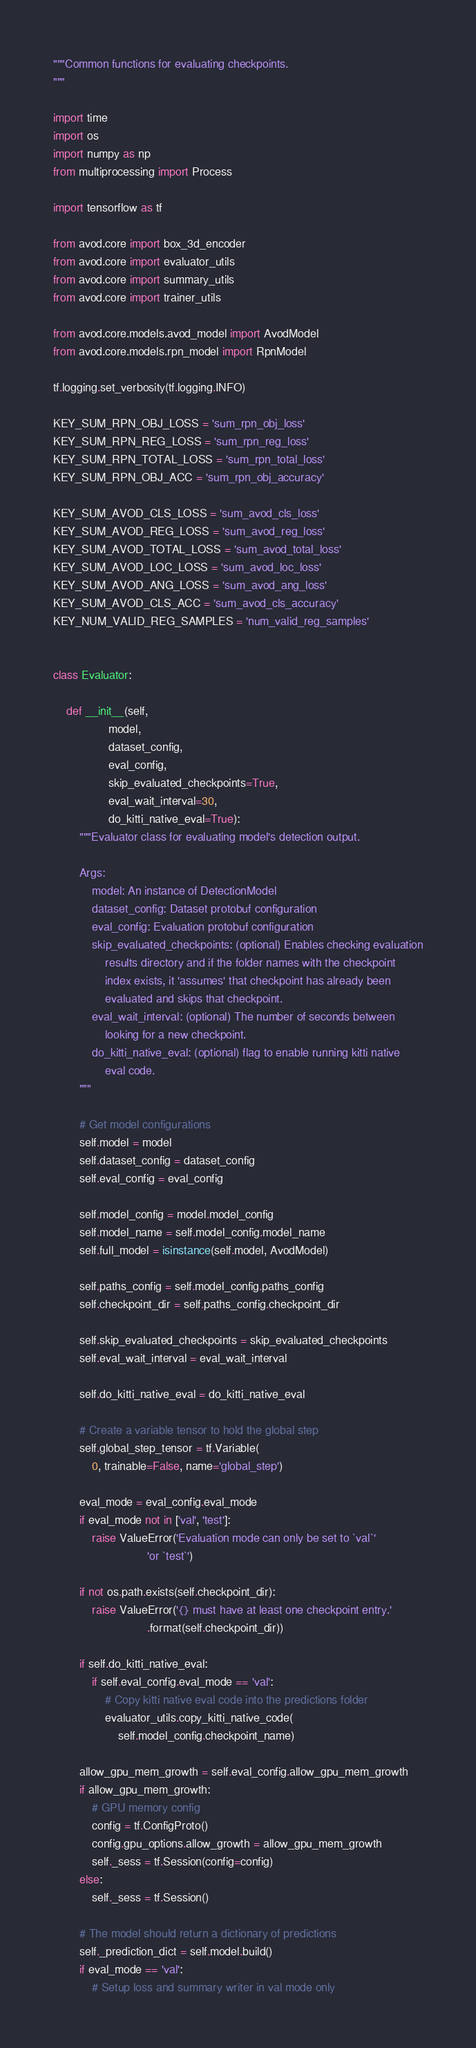<code> <loc_0><loc_0><loc_500><loc_500><_Python_>"""Common functions for evaluating checkpoints.
"""

import time
import os
import numpy as np
from multiprocessing import Process

import tensorflow as tf

from avod.core import box_3d_encoder
from avod.core import evaluator_utils
from avod.core import summary_utils
from avod.core import trainer_utils

from avod.core.models.avod_model import AvodModel
from avod.core.models.rpn_model import RpnModel

tf.logging.set_verbosity(tf.logging.INFO)

KEY_SUM_RPN_OBJ_LOSS = 'sum_rpn_obj_loss'
KEY_SUM_RPN_REG_LOSS = 'sum_rpn_reg_loss'
KEY_SUM_RPN_TOTAL_LOSS = 'sum_rpn_total_loss'
KEY_SUM_RPN_OBJ_ACC = 'sum_rpn_obj_accuracy'

KEY_SUM_AVOD_CLS_LOSS = 'sum_avod_cls_loss'
KEY_SUM_AVOD_REG_LOSS = 'sum_avod_reg_loss'
KEY_SUM_AVOD_TOTAL_LOSS = 'sum_avod_total_loss'
KEY_SUM_AVOD_LOC_LOSS = 'sum_avod_loc_loss'
KEY_SUM_AVOD_ANG_LOSS = 'sum_avod_ang_loss'
KEY_SUM_AVOD_CLS_ACC = 'sum_avod_cls_accuracy'
KEY_NUM_VALID_REG_SAMPLES = 'num_valid_reg_samples'


class Evaluator:

    def __init__(self,
                 model,
                 dataset_config,
                 eval_config,
                 skip_evaluated_checkpoints=True,
                 eval_wait_interval=30,
                 do_kitti_native_eval=True):
        """Evaluator class for evaluating model's detection output.

        Args:
            model: An instance of DetectionModel
            dataset_config: Dataset protobuf configuration
            eval_config: Evaluation protobuf configuration
            skip_evaluated_checkpoints: (optional) Enables checking evaluation
                results directory and if the folder names with the checkpoint
                index exists, it 'assumes' that checkpoint has already been
                evaluated and skips that checkpoint.
            eval_wait_interval: (optional) The number of seconds between
                looking for a new checkpoint.
            do_kitti_native_eval: (optional) flag to enable running kitti native
                eval code.
        """

        # Get model configurations
        self.model = model
        self.dataset_config = dataset_config
        self.eval_config = eval_config

        self.model_config = model.model_config
        self.model_name = self.model_config.model_name
        self.full_model = isinstance(self.model, AvodModel)

        self.paths_config = self.model_config.paths_config
        self.checkpoint_dir = self.paths_config.checkpoint_dir

        self.skip_evaluated_checkpoints = skip_evaluated_checkpoints
        self.eval_wait_interval = eval_wait_interval

        self.do_kitti_native_eval = do_kitti_native_eval

        # Create a variable tensor to hold the global step
        self.global_step_tensor = tf.Variable(
            0, trainable=False, name='global_step')

        eval_mode = eval_config.eval_mode
        if eval_mode not in ['val', 'test']:
            raise ValueError('Evaluation mode can only be set to `val`'
                             'or `test`')

        if not os.path.exists(self.checkpoint_dir):
            raise ValueError('{} must have at least one checkpoint entry.'
                             .format(self.checkpoint_dir))

        if self.do_kitti_native_eval:
            if self.eval_config.eval_mode == 'val':
                # Copy kitti native eval code into the predictions folder
                evaluator_utils.copy_kitti_native_code(
                    self.model_config.checkpoint_name)

        allow_gpu_mem_growth = self.eval_config.allow_gpu_mem_growth
        if allow_gpu_mem_growth:
            # GPU memory config
            config = tf.ConfigProto()
            config.gpu_options.allow_growth = allow_gpu_mem_growth
            self._sess = tf.Session(config=config)
        else:
            self._sess = tf.Session()

        # The model should return a dictionary of predictions
        self._prediction_dict = self.model.build()
        if eval_mode == 'val':
            # Setup loss and summary writer in val mode only</code> 